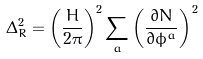Convert formula to latex. <formula><loc_0><loc_0><loc_500><loc_500>\Delta _ { R } ^ { 2 } = \left ( \frac { H } { 2 \pi } \right ) ^ { 2 } \sum _ { a } \left ( \frac { \partial N } { \partial \phi ^ { a } } \right ) ^ { 2 }</formula> 